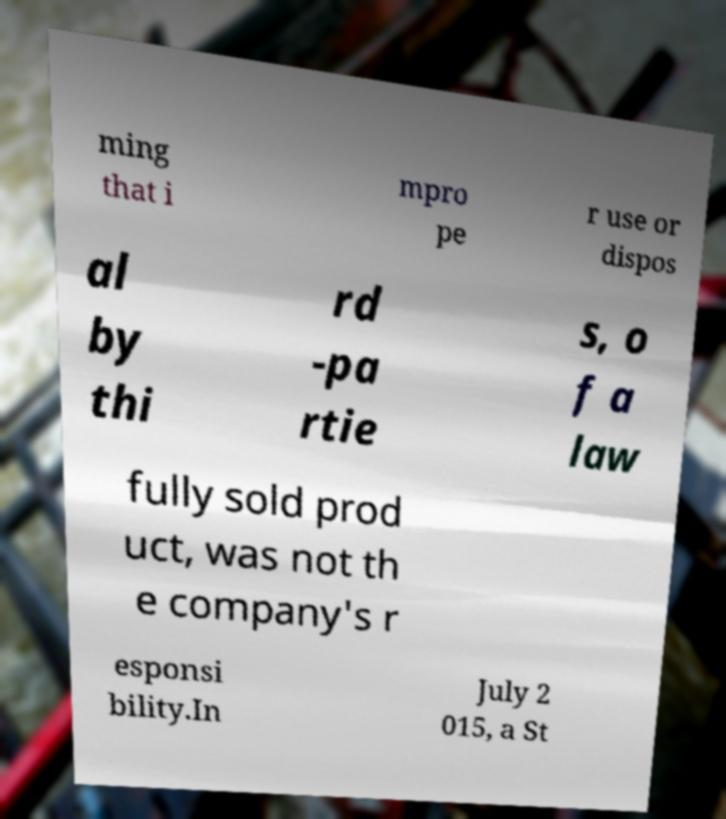Please read and relay the text visible in this image. What does it say? ming that i mpro pe r use or dispos al by thi rd -pa rtie s, o f a law fully sold prod uct, was not th e company's r esponsi bility.In July 2 015, a St 